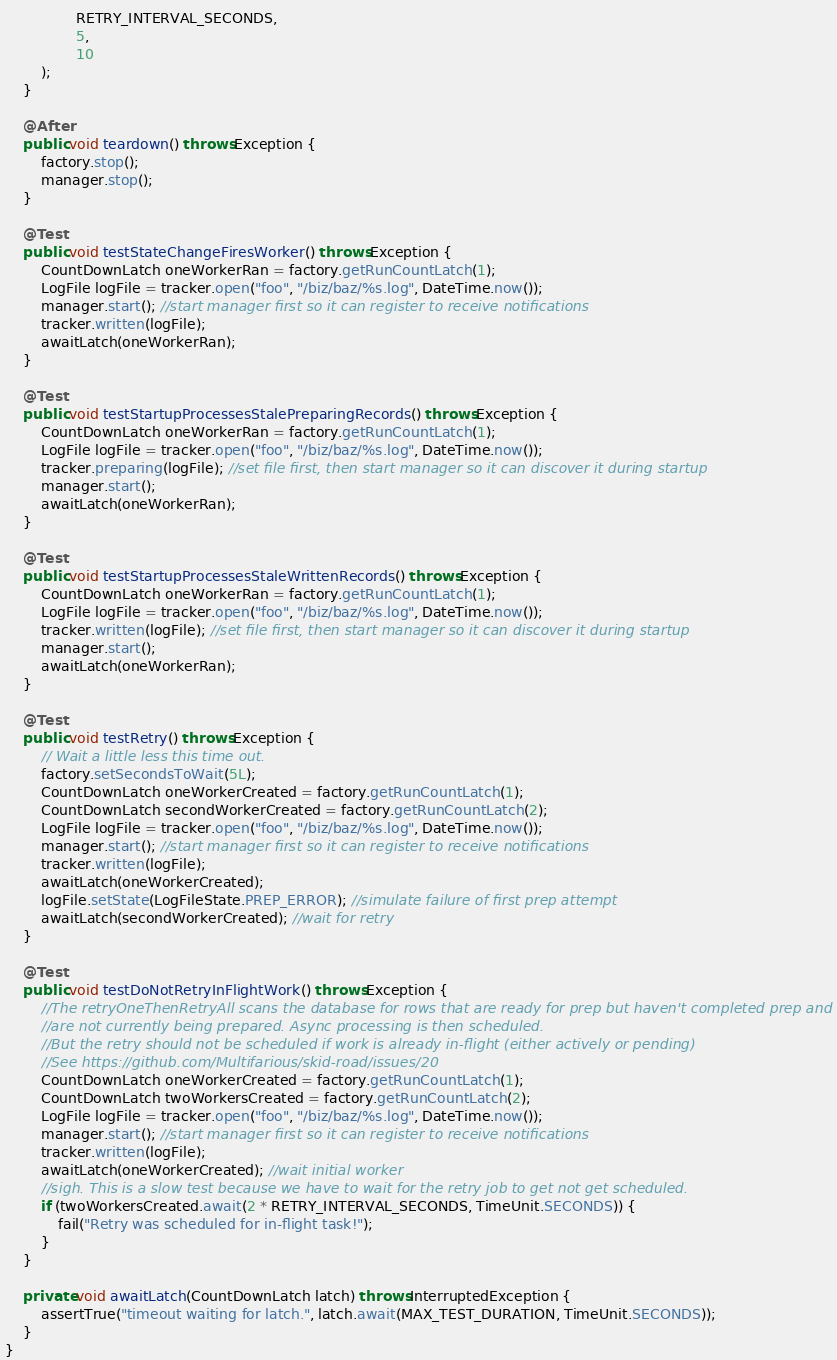Convert code to text. <code><loc_0><loc_0><loc_500><loc_500><_Java_>                RETRY_INTERVAL_SECONDS,
                5,
                10
        );
    }

    @After
    public void teardown() throws Exception {
        factory.stop();
        manager.stop();
    }

    @Test
    public void testStateChangeFiresWorker() throws Exception {
        CountDownLatch oneWorkerRan = factory.getRunCountLatch(1);
        LogFile logFile = tracker.open("foo", "/biz/baz/%s.log", DateTime.now());
        manager.start(); //start manager first so it can register to receive notifications
        tracker.written(logFile);
        awaitLatch(oneWorkerRan);
    }

    @Test
    public void testStartupProcessesStalePreparingRecords() throws Exception {
        CountDownLatch oneWorkerRan = factory.getRunCountLatch(1);
        LogFile logFile = tracker.open("foo", "/biz/baz/%s.log", DateTime.now());
        tracker.preparing(logFile); //set file first, then start manager so it can discover it during startup
        manager.start();
        awaitLatch(oneWorkerRan);
    }

    @Test
    public void testStartupProcessesStaleWrittenRecords() throws Exception {
        CountDownLatch oneWorkerRan = factory.getRunCountLatch(1);
        LogFile logFile = tracker.open("foo", "/biz/baz/%s.log", DateTime.now());
        tracker.written(logFile); //set file first, then start manager so it can discover it during startup
        manager.start();
        awaitLatch(oneWorkerRan);
    }

    @Test
    public void testRetry() throws Exception {
        // Wait a little less this time out.
        factory.setSecondsToWait(5L);
        CountDownLatch oneWorkerCreated = factory.getRunCountLatch(1);
        CountDownLatch secondWorkerCreated = factory.getRunCountLatch(2);
        LogFile logFile = tracker.open("foo", "/biz/baz/%s.log", DateTime.now());
        manager.start(); //start manager first so it can register to receive notifications
        tracker.written(logFile);
        awaitLatch(oneWorkerCreated);
        logFile.setState(LogFileState.PREP_ERROR); //simulate failure of first prep attempt
        awaitLatch(secondWorkerCreated); //wait for retry
    }

    @Test
    public void testDoNotRetryInFlightWork() throws Exception {
        //The retryOneThenRetryAll scans the database for rows that are ready for prep but haven't completed prep and
        //are not currently being prepared. Async processing is then scheduled.
        //But the retry should not be scheduled if work is already in-flight (either actively or pending)
        //See https://github.com/Multifarious/skid-road/issues/20
        CountDownLatch oneWorkerCreated = factory.getRunCountLatch(1);
        CountDownLatch twoWorkersCreated = factory.getRunCountLatch(2);
        LogFile logFile = tracker.open("foo", "/biz/baz/%s.log", DateTime.now());
        manager.start(); //start manager first so it can register to receive notifications
        tracker.written(logFile);
        awaitLatch(oneWorkerCreated); //wait initial worker
        //sigh. This is a slow test because we have to wait for the retry job to get not get scheduled.
        if (twoWorkersCreated.await(2 * RETRY_INTERVAL_SECONDS, TimeUnit.SECONDS)) {
            fail("Retry was scheduled for in-flight task!");
        }
    }

    private void awaitLatch(CountDownLatch latch) throws InterruptedException {
        assertTrue("timeout waiting for latch.", latch.await(MAX_TEST_DURATION, TimeUnit.SECONDS));
    }
}
</code> 